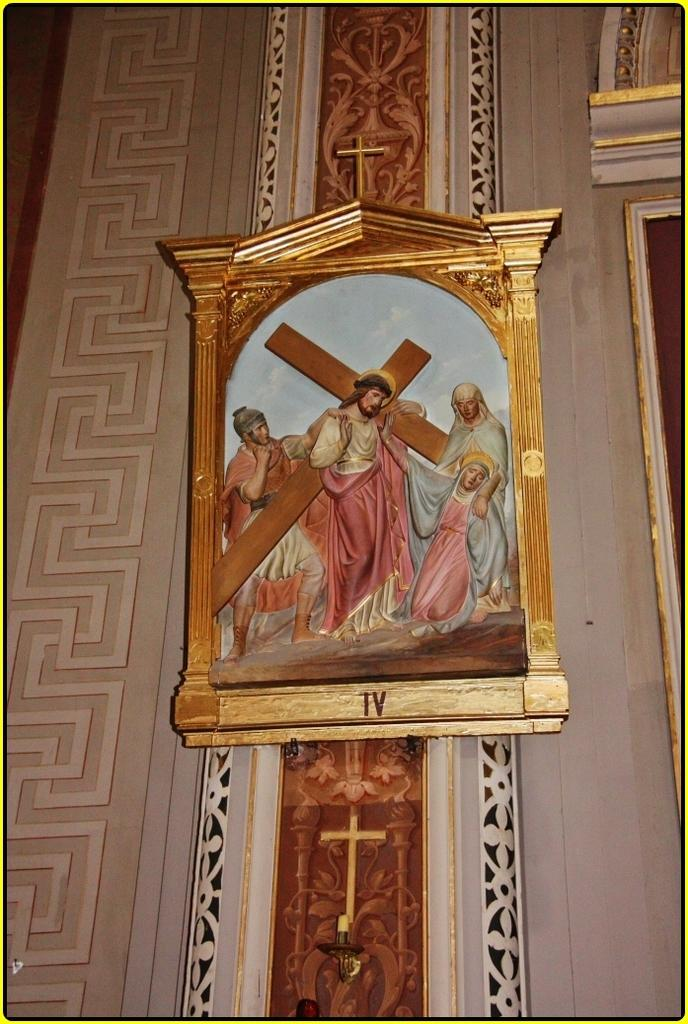<image>
Share a concise interpretation of the image provided. A painted portrait of Jesus with the letters IV below. 